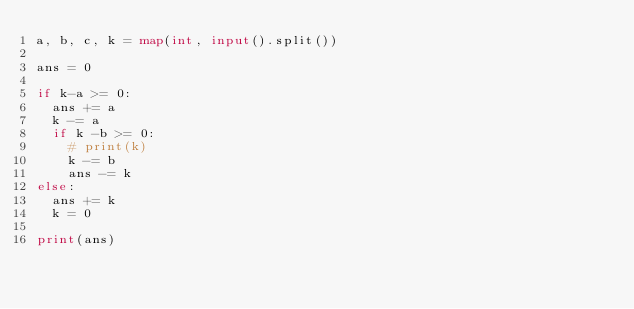Convert code to text. <code><loc_0><loc_0><loc_500><loc_500><_Python_>a, b, c, k = map(int, input().split())

ans = 0

if k-a >= 0:
  ans += a
  k -= a
  if k -b >= 0:
    # print(k)
    k -= b
    ans -= k
else:
  ans += k
  k = 0

print(ans)</code> 